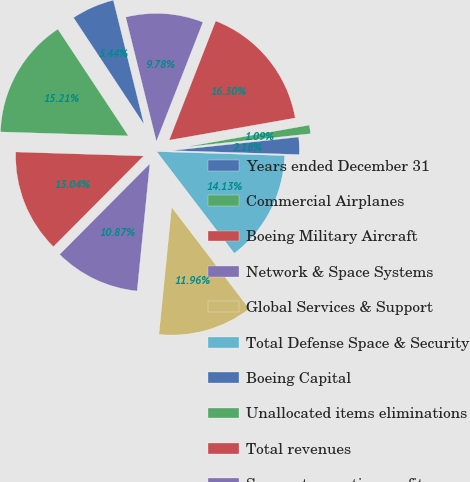Convert chart. <chart><loc_0><loc_0><loc_500><loc_500><pie_chart><fcel>Years ended December 31<fcel>Commercial Airplanes<fcel>Boeing Military Aircraft<fcel>Network & Space Systems<fcel>Global Services & Support<fcel>Total Defense Space & Security<fcel>Boeing Capital<fcel>Unallocated items eliminations<fcel>Total revenues<fcel>Segment operating profit<nl><fcel>5.44%<fcel>15.21%<fcel>13.04%<fcel>10.87%<fcel>11.96%<fcel>14.13%<fcel>2.18%<fcel>1.09%<fcel>16.3%<fcel>9.78%<nl></chart> 